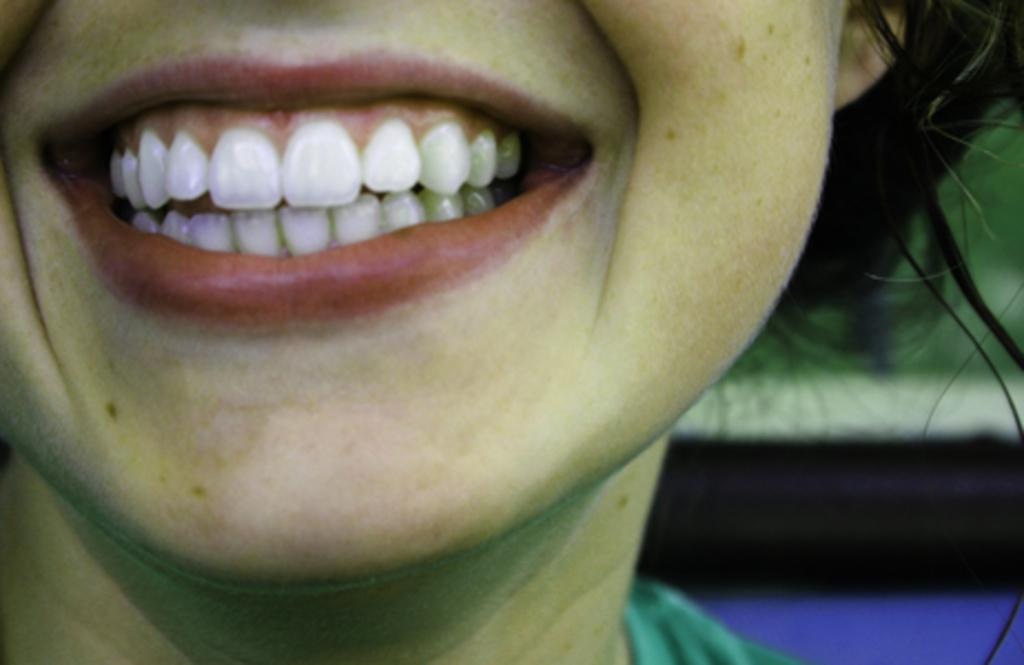What is present in the image? There is a person in the image. What part of the person's body can be seen in the image? The person's teeth and lips are visible in the image. What type of scarf is the laborer wearing in the image? There is no laborer or scarf present in the image. What is the texture of the person's clothing in the image? The provided facts do not mention the texture of the person's clothing, so we cannot determine that information from the image. 